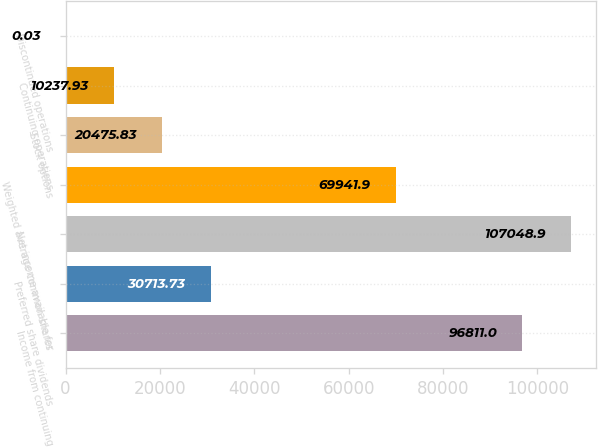Convert chart to OTSL. <chart><loc_0><loc_0><loc_500><loc_500><bar_chart><fcel>Income from continuing<fcel>Preferred share dividends<fcel>Net income available for<fcel>Weighted average common shares<fcel>Stock options<fcel>Continuing operations<fcel>Discontinued operations<nl><fcel>96811<fcel>30713.7<fcel>107049<fcel>69941.9<fcel>20475.8<fcel>10237.9<fcel>0.03<nl></chart> 